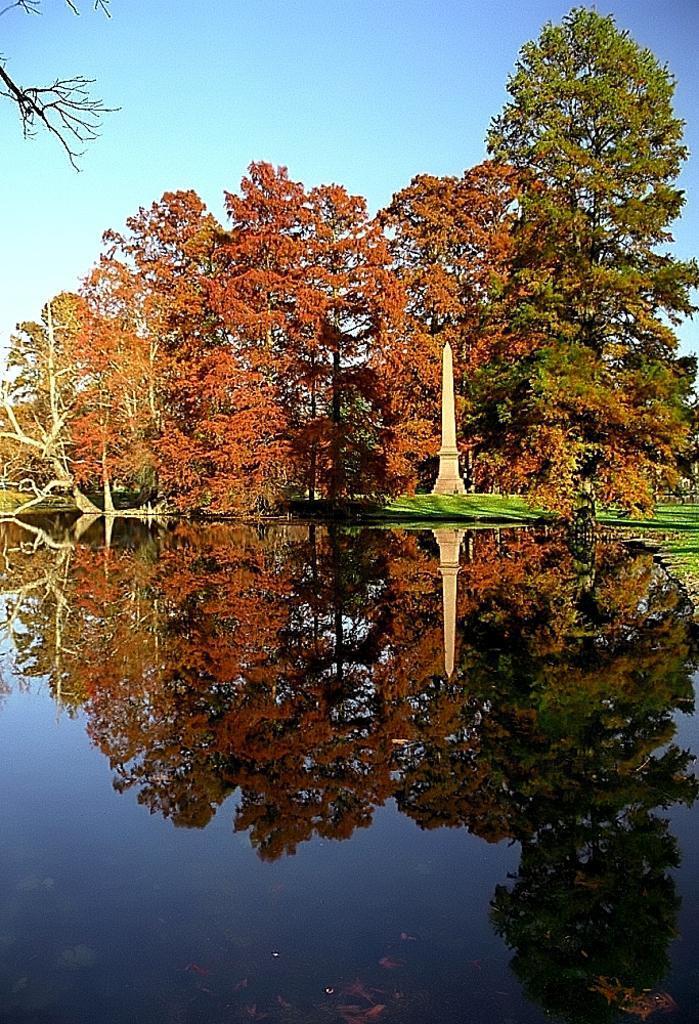Please provide a concise description of this image. There is a water on which, there is a mirror image of trees and a tower. In the background, there are trees, tower, grass on the ground and there is blue sky. 